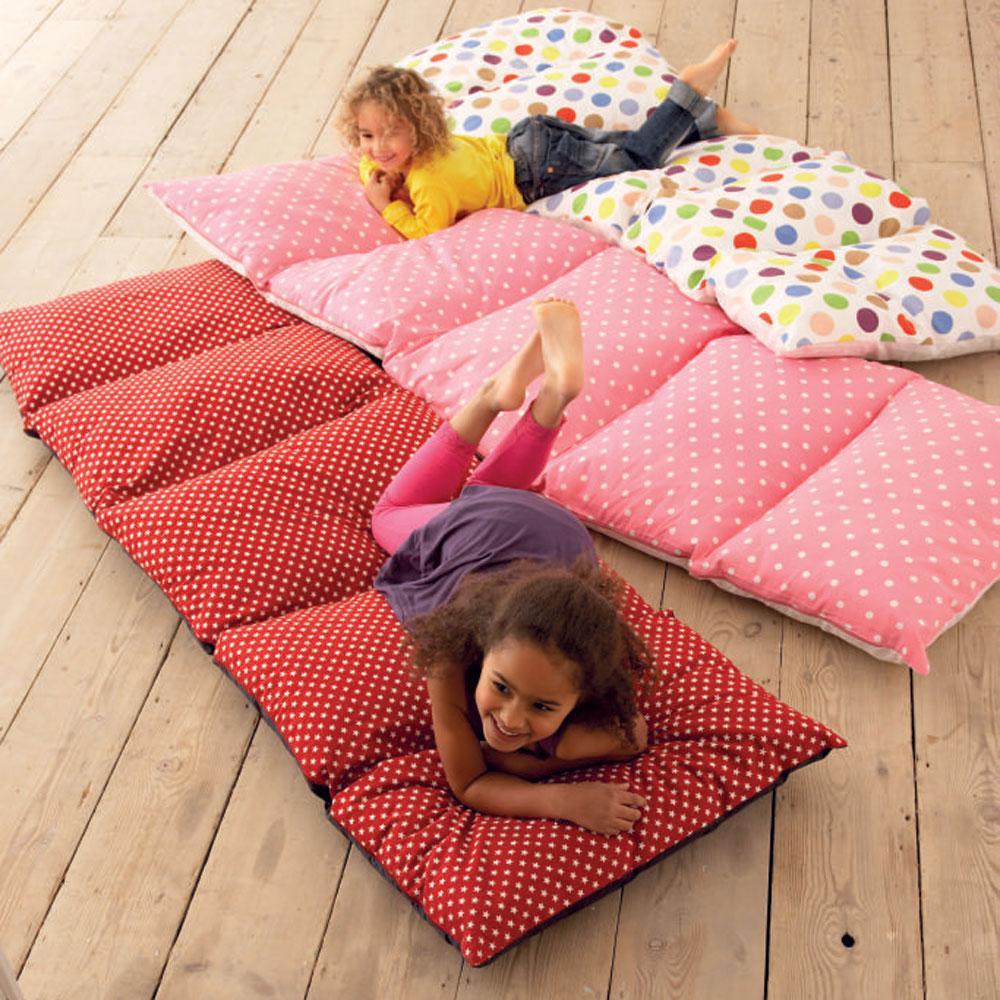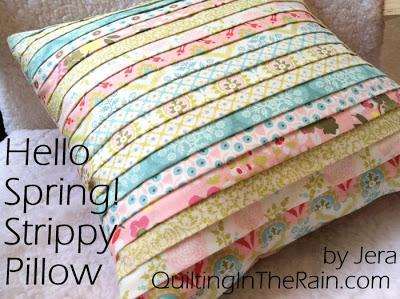The first image is the image on the left, the second image is the image on the right. Given the left and right images, does the statement "there are two children laying on mats on a wood floor" hold true? Answer yes or no. Yes. 